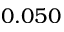<formula> <loc_0><loc_0><loc_500><loc_500>0 . 0 5 0</formula> 